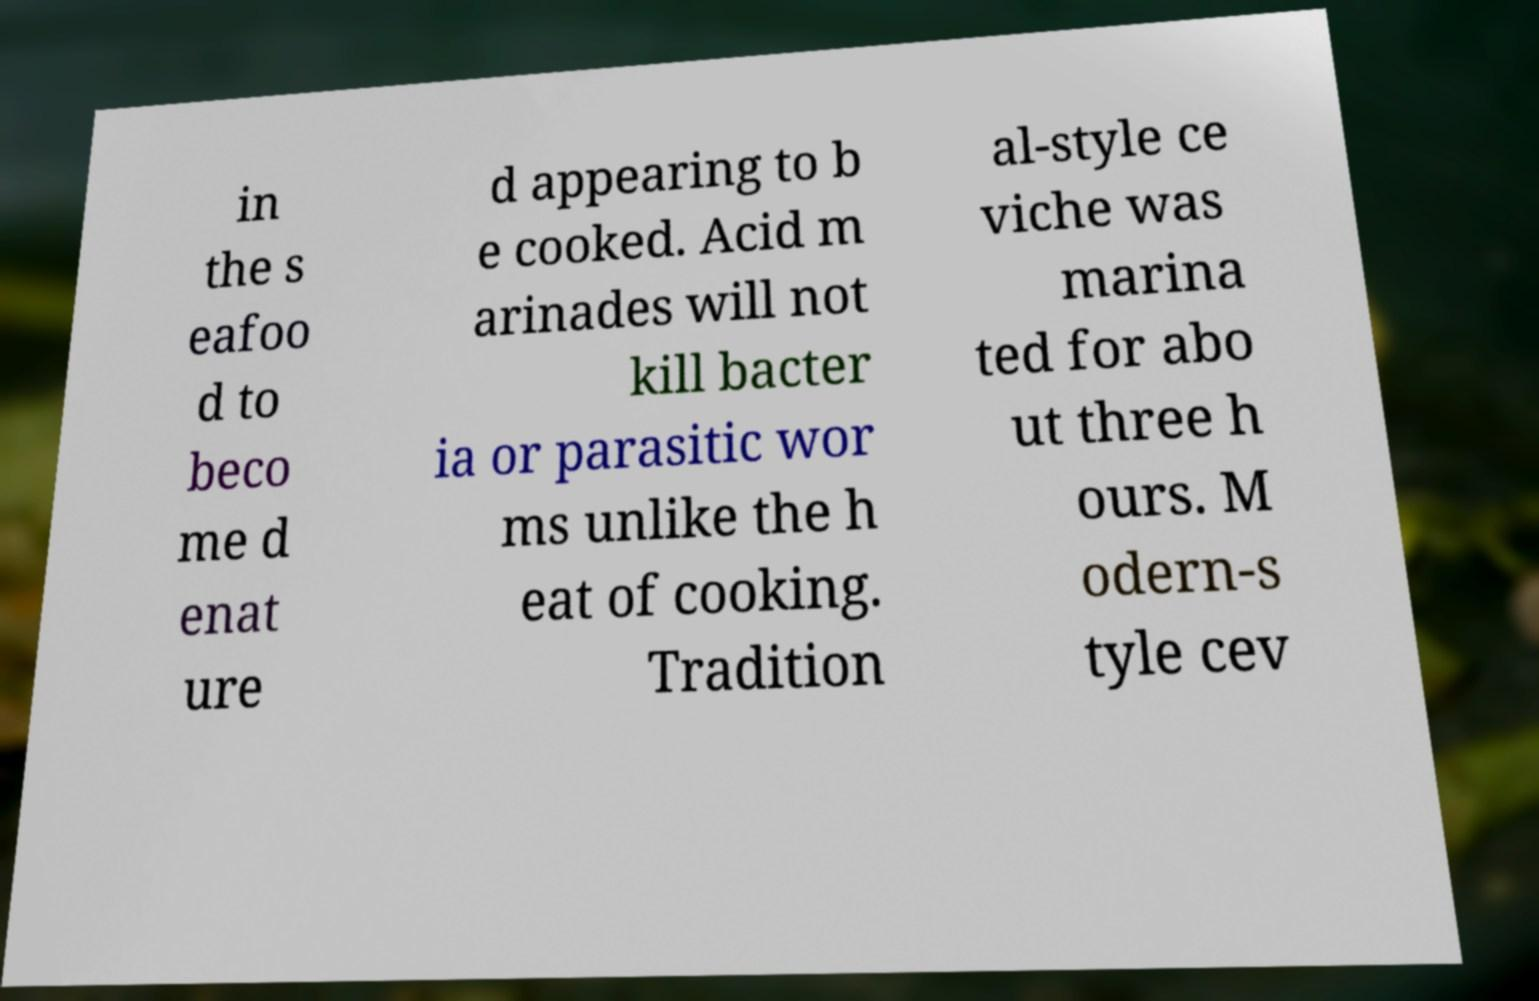What messages or text are displayed in this image? I need them in a readable, typed format. in the s eafoo d to beco me d enat ure d appearing to b e cooked. Acid m arinades will not kill bacter ia or parasitic wor ms unlike the h eat of cooking. Tradition al-style ce viche was marina ted for abo ut three h ours. M odern-s tyle cev 